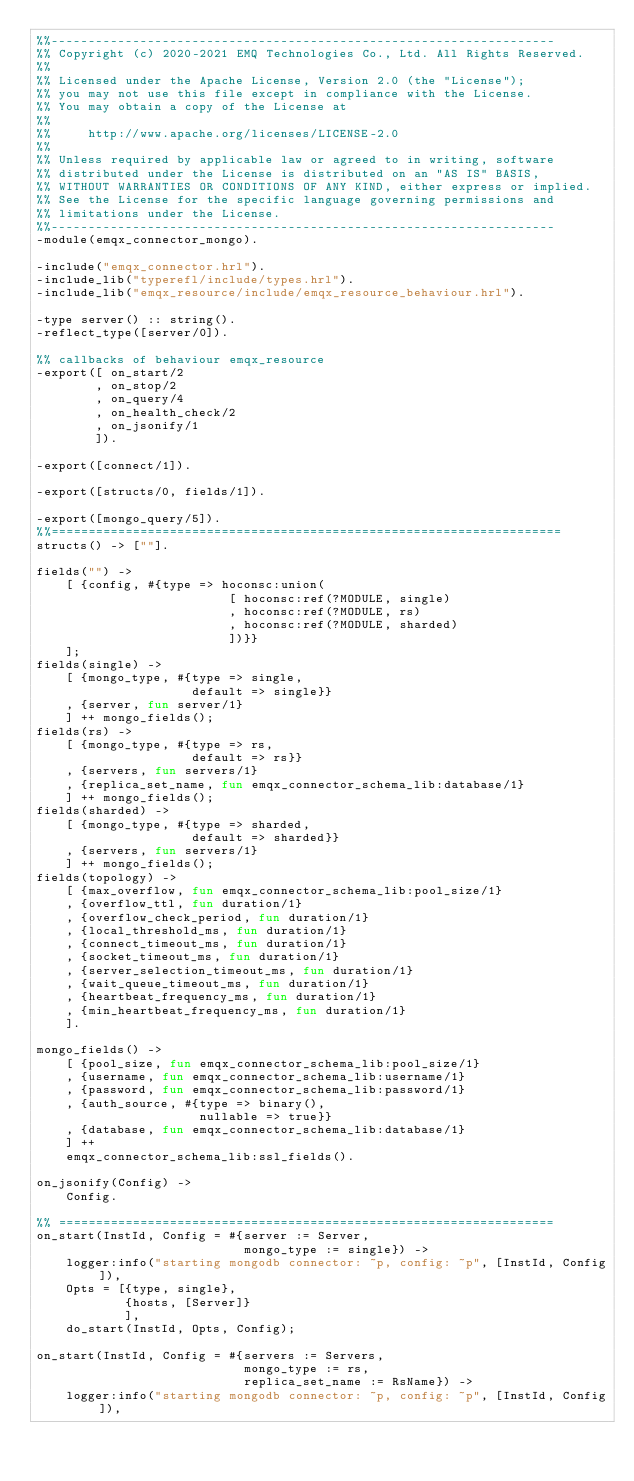<code> <loc_0><loc_0><loc_500><loc_500><_Erlang_>%%--------------------------------------------------------------------
%% Copyright (c) 2020-2021 EMQ Technologies Co., Ltd. All Rights Reserved.
%%
%% Licensed under the Apache License, Version 2.0 (the "License");
%% you may not use this file except in compliance with the License.
%% You may obtain a copy of the License at
%%
%%     http://www.apache.org/licenses/LICENSE-2.0
%%
%% Unless required by applicable law or agreed to in writing, software
%% distributed under the License is distributed on an "AS IS" BASIS,
%% WITHOUT WARRANTIES OR CONDITIONS OF ANY KIND, either express or implied.
%% See the License for the specific language governing permissions and
%% limitations under the License.
%%--------------------------------------------------------------------
-module(emqx_connector_mongo).

-include("emqx_connector.hrl").
-include_lib("typerefl/include/types.hrl").
-include_lib("emqx_resource/include/emqx_resource_behaviour.hrl").

-type server() :: string().
-reflect_type([server/0]).

%% callbacks of behaviour emqx_resource
-export([ on_start/2
        , on_stop/2
        , on_query/4
        , on_health_check/2
        , on_jsonify/1
        ]).

-export([connect/1]).

-export([structs/0, fields/1]).

-export([mongo_query/5]).
%%=====================================================================
structs() -> [""].

fields("") ->
    [ {config, #{type => hoconsc:union(
                          [ hoconsc:ref(?MODULE, single)
                          , hoconsc:ref(?MODULE, rs)
                          , hoconsc:ref(?MODULE, sharded)
                          ])}}
    ];
fields(single) ->
    [ {mongo_type, #{type => single,
                     default => single}}
    , {server, fun server/1}
    ] ++ mongo_fields();
fields(rs) ->
    [ {mongo_type, #{type => rs,
                     default => rs}}
    , {servers, fun servers/1}
    , {replica_set_name, fun emqx_connector_schema_lib:database/1}
    ] ++ mongo_fields();
fields(sharded) ->
    [ {mongo_type, #{type => sharded,
                     default => sharded}}
    , {servers, fun servers/1}
    ] ++ mongo_fields();
fields(topology) ->
    [ {max_overflow, fun emqx_connector_schema_lib:pool_size/1}
    , {overflow_ttl, fun duration/1}
    , {overflow_check_period, fun duration/1}
    , {local_threshold_ms, fun duration/1}
    , {connect_timeout_ms, fun duration/1}
    , {socket_timeout_ms, fun duration/1}
    , {server_selection_timeout_ms, fun duration/1}
    , {wait_queue_timeout_ms, fun duration/1}
    , {heartbeat_frequency_ms, fun duration/1}
    , {min_heartbeat_frequency_ms, fun duration/1}
    ].

mongo_fields() ->
    [ {pool_size, fun emqx_connector_schema_lib:pool_size/1}
    , {username, fun emqx_connector_schema_lib:username/1}
    , {password, fun emqx_connector_schema_lib:password/1}
    , {auth_source, #{type => binary(),
                      nullable => true}}
    , {database, fun emqx_connector_schema_lib:database/1}
    ] ++
    emqx_connector_schema_lib:ssl_fields().

on_jsonify(Config) ->
    Config.

%% ===================================================================
on_start(InstId, Config = #{server := Server,
                            mongo_type := single}) ->
    logger:info("starting mongodb connector: ~p, config: ~p", [InstId, Config]),
    Opts = [{type, single},
            {hosts, [Server]}
            ],
    do_start(InstId, Opts, Config);

on_start(InstId, Config = #{servers := Servers,
                            mongo_type := rs,
                            replica_set_name := RsName}) ->
    logger:info("starting mongodb connector: ~p, config: ~p", [InstId, Config]),</code> 